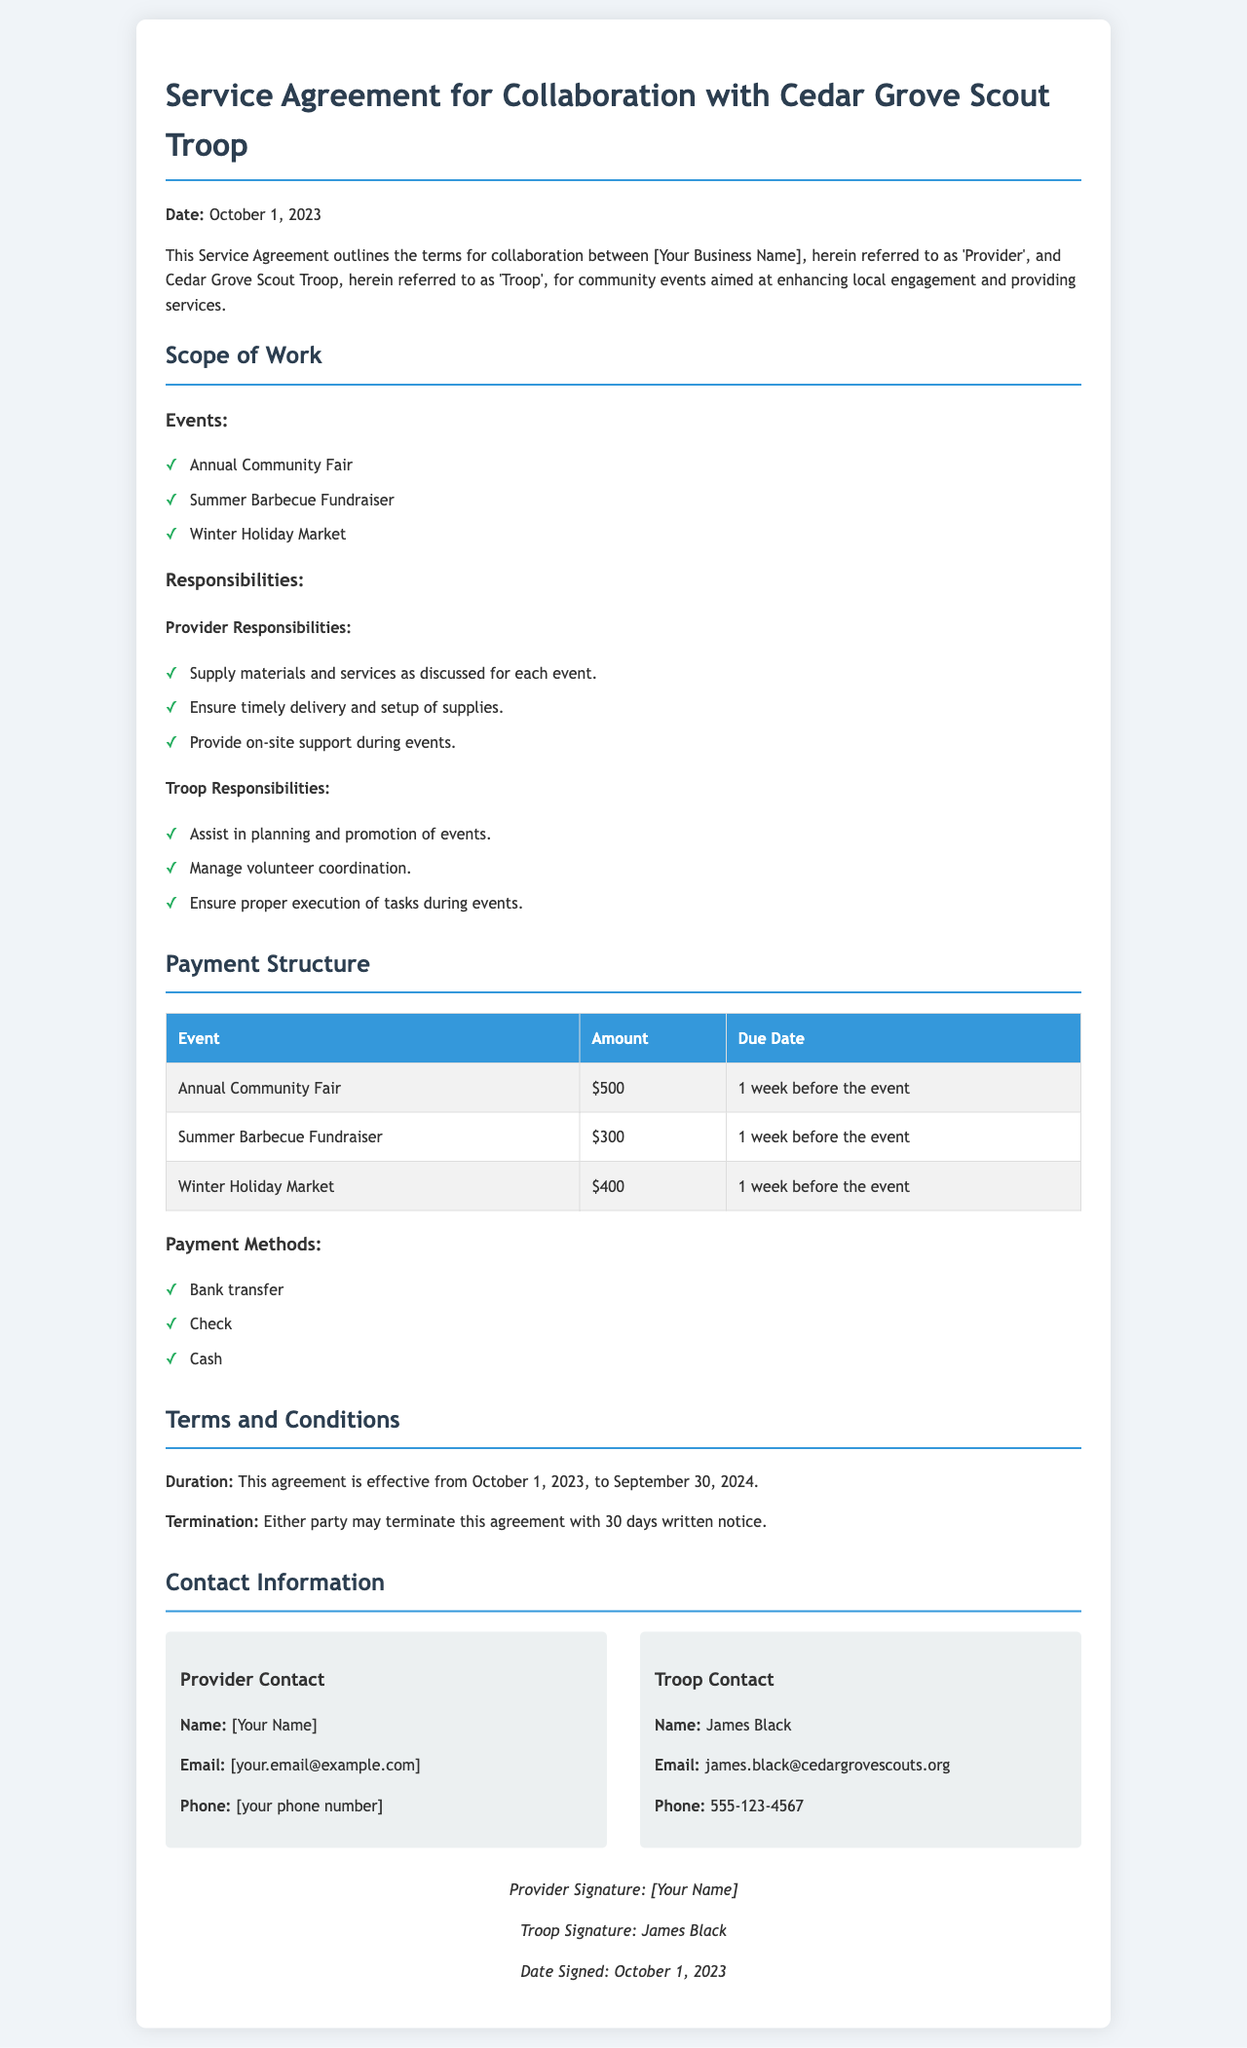What is the date of the agreement? The date of the agreement is stated at the top of the document.
Answer: October 1, 2023 Who is the contact person for the Troop? The document lists the name of the Troop contact in the contact information section.
Answer: James Black How much is the payment for the Annual Community Fair? The payment details for each event are provided in a table within the document.
Answer: $500 What is the termination notice period required? The termination clause specifies the notice period that needs to be provided for termination of the agreement.
Answer: 30 days Which event has a payment due date of one week before the event? Reviewing the payment table, all specified events have the same due date.
Answer: All events What is the effective duration of this service agreement? The duration of the agreement is explicitly stated in the terms and conditions section.
Answer: October 1, 2023, to September 30, 2024 What payment methods are accepted according to the document? The payment methods can be found listed in the payment structure section.
Answer: Bank transfer, Check, Cash What is the main purpose of this service agreement? The introductory paragraph describes the primary objective of the collaboration outlined in the agreement.
Answer: Collaboration for community events What support is the Provider responsible for during the events? The Provider responsibilities list outlines what support is to be provided.
Answer: On-site support 